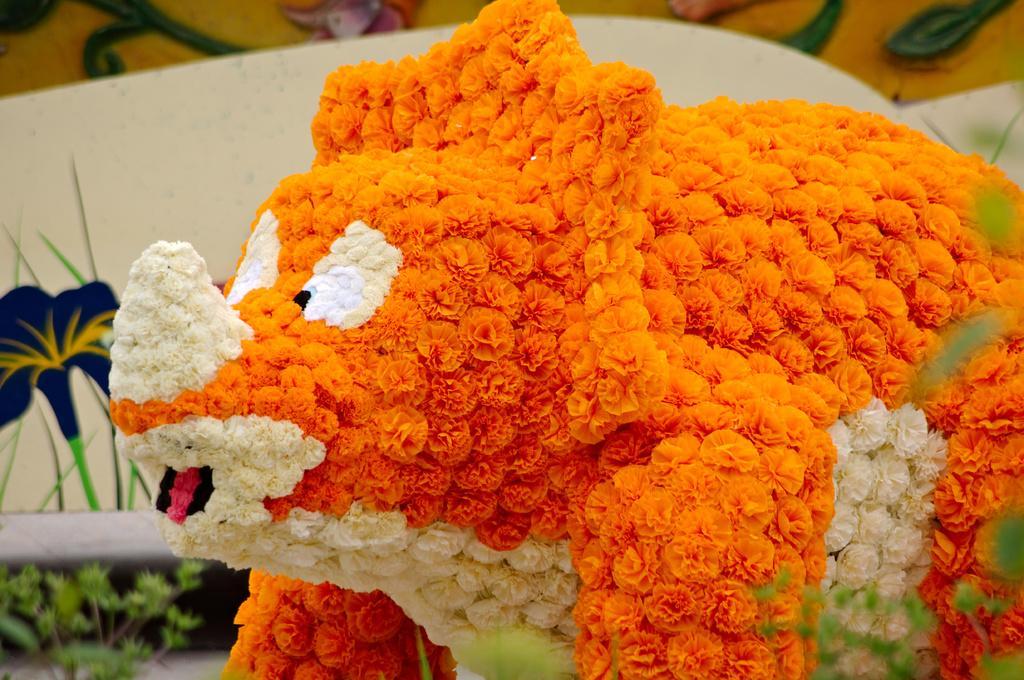Can you describe this image briefly? In this image I can see a plate , on top of plate I can see bunch of colorful flowers. 